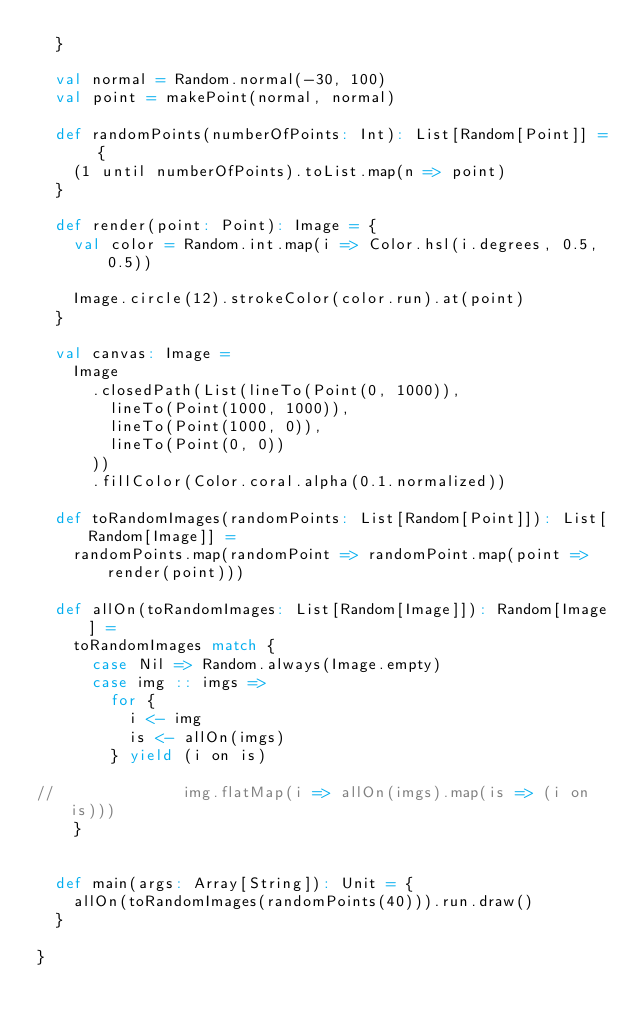<code> <loc_0><loc_0><loc_500><loc_500><_Scala_>  }

  val normal = Random.normal(-30, 100)
  val point = makePoint(normal, normal)

  def randomPoints(numberOfPoints: Int): List[Random[Point]] = {
    (1 until numberOfPoints).toList.map(n => point)
  }

  def render(point: Point): Image = {
    val color = Random.int.map(i => Color.hsl(i.degrees, 0.5, 0.5))

    Image.circle(12).strokeColor(color.run).at(point)
  }

  val canvas: Image =
    Image
      .closedPath(List(lineTo(Point(0, 1000)),
        lineTo(Point(1000, 1000)),
        lineTo(Point(1000, 0)),
        lineTo(Point(0, 0))
      ))
      .fillColor(Color.coral.alpha(0.1.normalized))

  def toRandomImages(randomPoints: List[Random[Point]]): List[Random[Image]] =
    randomPoints.map(randomPoint => randomPoint.map(point => render(point)))

  def allOn(toRandomImages: List[Random[Image]]): Random[Image] =
    toRandomImages match {
      case Nil => Random.always(Image.empty)
      case img :: imgs =>
        for {
          i <- img
          is <- allOn(imgs)
        } yield (i on is)

//              img.flatMap(i => allOn(imgs).map(is => (i on is)))
    }


  def main(args: Array[String]): Unit = {
    allOn(toRandomImages(randomPoints(40))).run.draw()
  }

}
</code> 